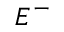Convert formula to latex. <formula><loc_0><loc_0><loc_500><loc_500>E ^ { - }</formula> 